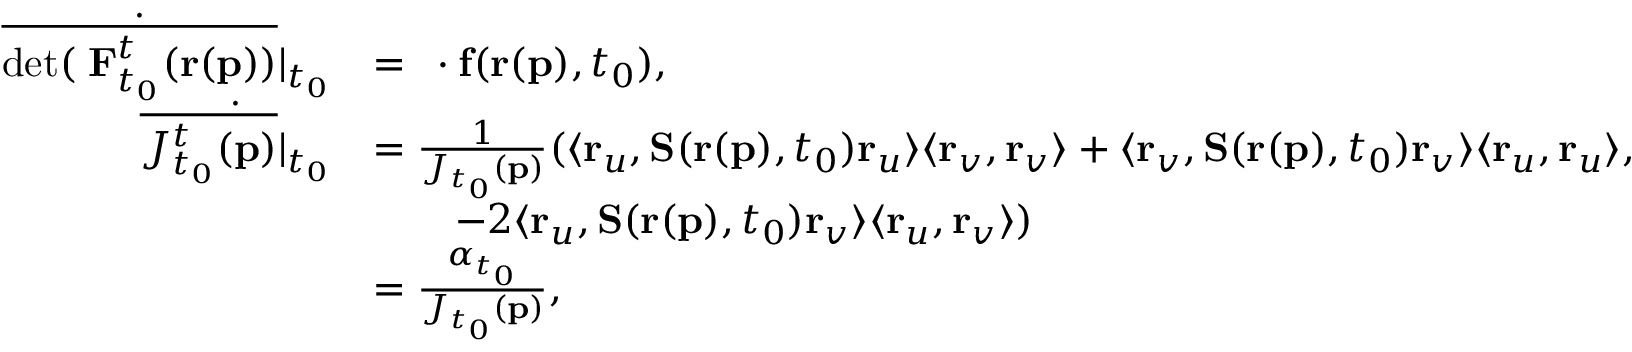<formula> <loc_0><loc_0><loc_500><loc_500>\begin{array} { r l } { \dot { \overline { { d e t ( \nabla F _ { t _ { 0 } } ^ { t } ( r ( p ) ) } } } | _ { t _ { 0 } } } & { = \nabla \cdot f ( r ( p ) , t _ { 0 } ) , } \\ { \dot { \overline { { J _ { t _ { 0 } } ^ { t } ( p ) } } | _ { t _ { 0 } } } } & { = \frac { 1 } { J _ { t _ { 0 } } ( p ) } ( \langle r _ { u } , S ( r ( p ) , t _ { 0 } ) r _ { u } \rangle \langle r _ { v } , r _ { v } \rangle + \langle r _ { v } , S ( r ( p ) , t _ { 0 } ) r _ { v } \rangle \langle r _ { u } , r _ { u } \rangle , } \\ & { \quad - 2 \langle r _ { u } , S ( r ( p ) , t _ { 0 } ) r _ { v } \rangle \langle r _ { u } , r _ { v } \rangle ) } \\ & { = \frac { \alpha _ { t _ { 0 } } } { J _ { t _ { 0 } } ( p ) } , } \end{array}</formula> 